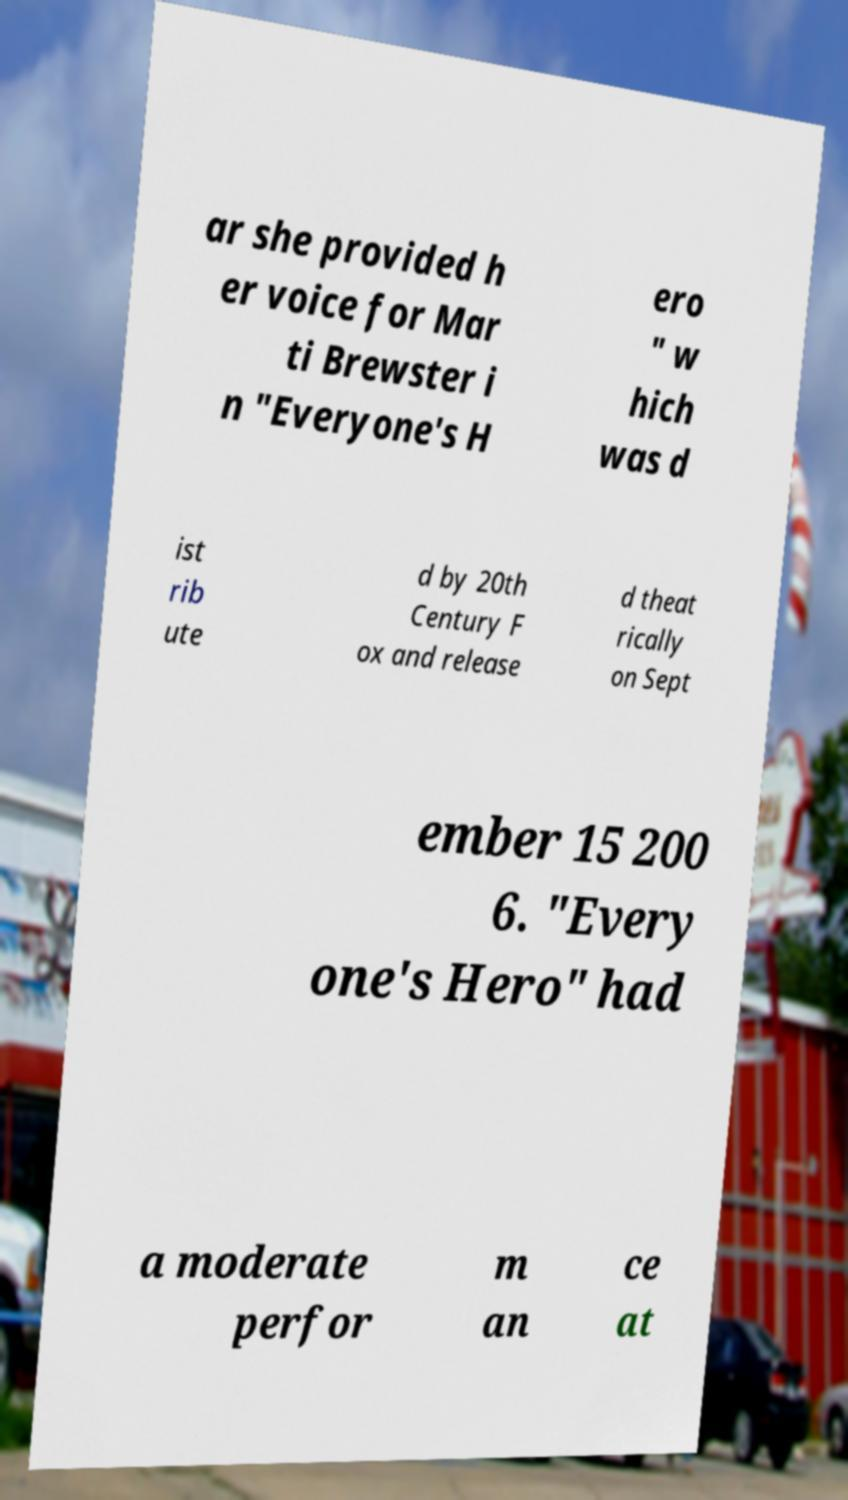Can you read and provide the text displayed in the image?This photo seems to have some interesting text. Can you extract and type it out for me? ar she provided h er voice for Mar ti Brewster i n "Everyone's H ero " w hich was d ist rib ute d by 20th Century F ox and release d theat rically on Sept ember 15 200 6. "Every one's Hero" had a moderate perfor m an ce at 